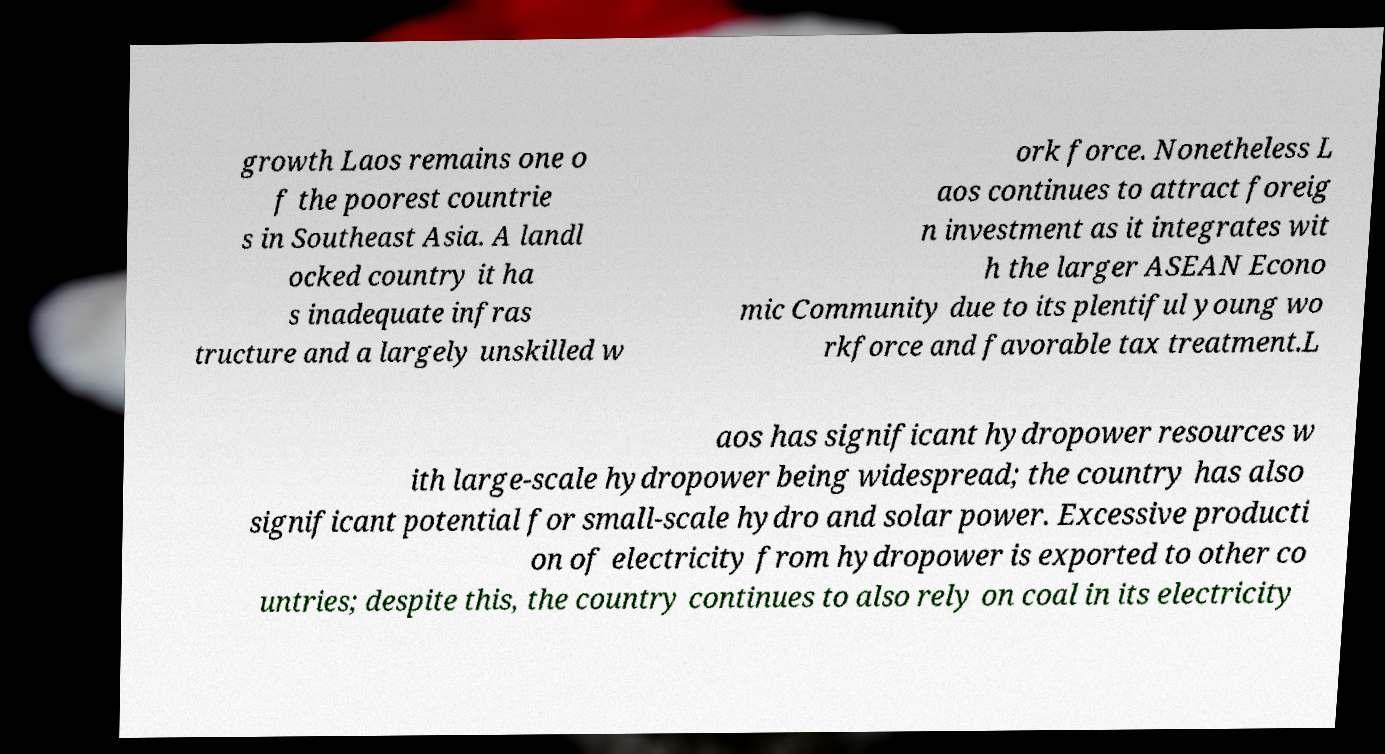Please read and relay the text visible in this image. What does it say? growth Laos remains one o f the poorest countrie s in Southeast Asia. A landl ocked country it ha s inadequate infras tructure and a largely unskilled w ork force. Nonetheless L aos continues to attract foreig n investment as it integrates wit h the larger ASEAN Econo mic Community due to its plentiful young wo rkforce and favorable tax treatment.L aos has significant hydropower resources w ith large-scale hydropower being widespread; the country has also significant potential for small-scale hydro and solar power. Excessive producti on of electricity from hydropower is exported to other co untries; despite this, the country continues to also rely on coal in its electricity 